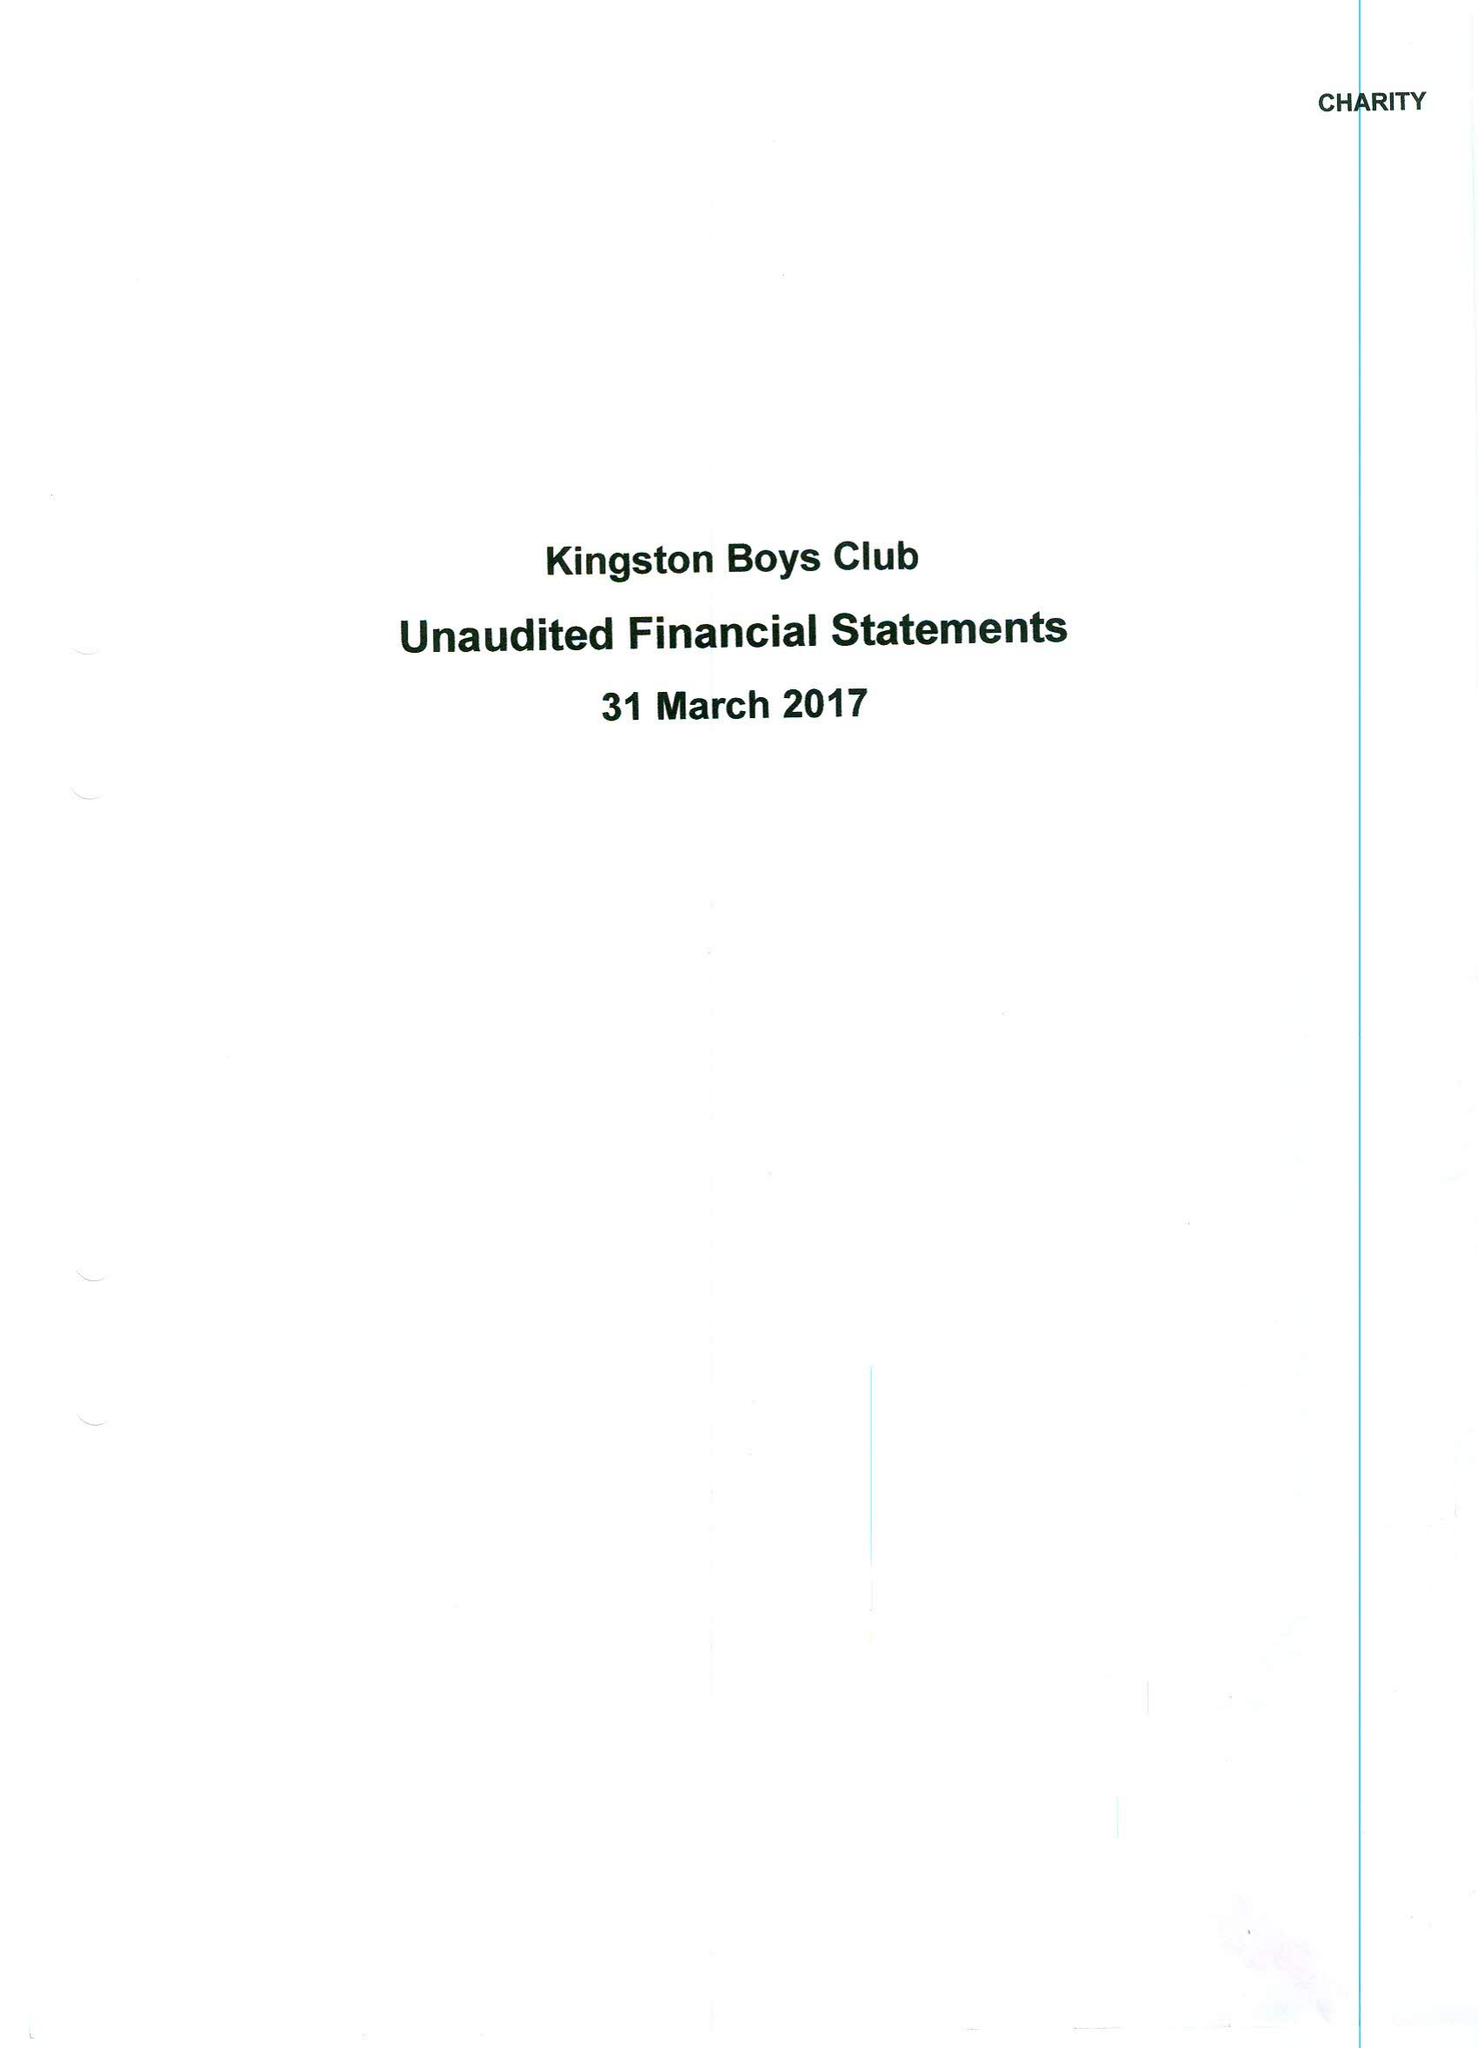What is the value for the charity_name?
Answer the question using a single word or phrase. Kingston Boys' Club 